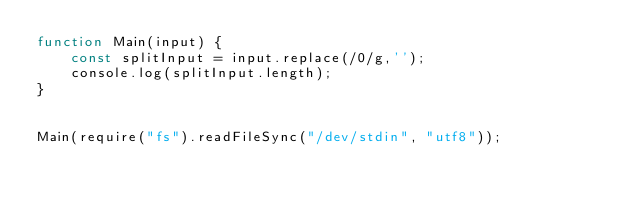Convert code to text. <code><loc_0><loc_0><loc_500><loc_500><_JavaScript_>function Main(input) {
    const splitInput = input.replace(/0/g,'');
    console.log(splitInput.length);
}
 
 
Main(require("fs").readFileSync("/dev/stdin", "utf8"));</code> 